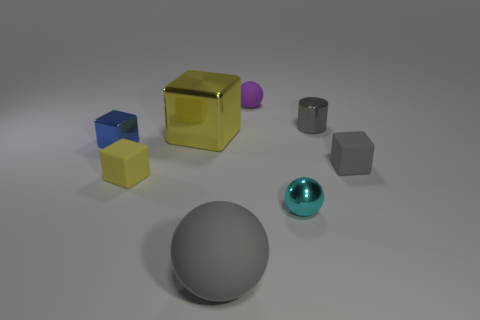Is there a rubber object of the same color as the big block?
Make the answer very short. Yes. Is the number of gray shiny cylinders left of the large yellow metallic object less than the number of tiny gray matte spheres?
Offer a very short reply. No. Do the yellow rubber object left of the metal ball and the cyan shiny object have the same size?
Your answer should be compact. Yes. What number of things are both behind the tiny yellow block and on the left side of the gray metal cylinder?
Ensure brevity in your answer.  3. What is the size of the matte cube on the right side of the big yellow object in front of the gray cylinder?
Provide a succinct answer. Small. Is the number of small gray cylinders to the left of the tiny cyan shiny object less than the number of cylinders behind the large yellow object?
Offer a terse response. Yes. There is a block that is to the right of the small purple object; is its color the same as the matte sphere that is to the left of the small purple rubber thing?
Your answer should be very brief. Yes. What material is the sphere that is both in front of the blue object and behind the big gray matte thing?
Give a very brief answer. Metal. Are there any small purple objects?
Provide a succinct answer. Yes. What shape is the tiny blue object that is made of the same material as the large block?
Offer a terse response. Cube. 